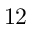<formula> <loc_0><loc_0><loc_500><loc_500>1 2</formula> 